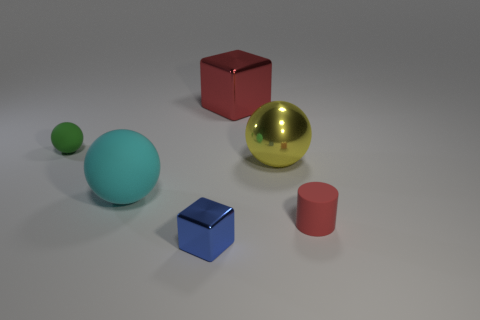Subtract all matte spheres. How many spheres are left? 1 Subtract all green balls. How many balls are left? 2 Add 1 spheres. How many objects exist? 7 Subtract 2 blocks. How many blocks are left? 0 Subtract all big objects. Subtract all small rubber cylinders. How many objects are left? 2 Add 3 tiny blue shiny blocks. How many tiny blue shiny blocks are left? 4 Add 3 green metal blocks. How many green metal blocks exist? 3 Subtract 1 blue cubes. How many objects are left? 5 Subtract all cylinders. How many objects are left? 5 Subtract all cyan cubes. Subtract all red cylinders. How many cubes are left? 2 